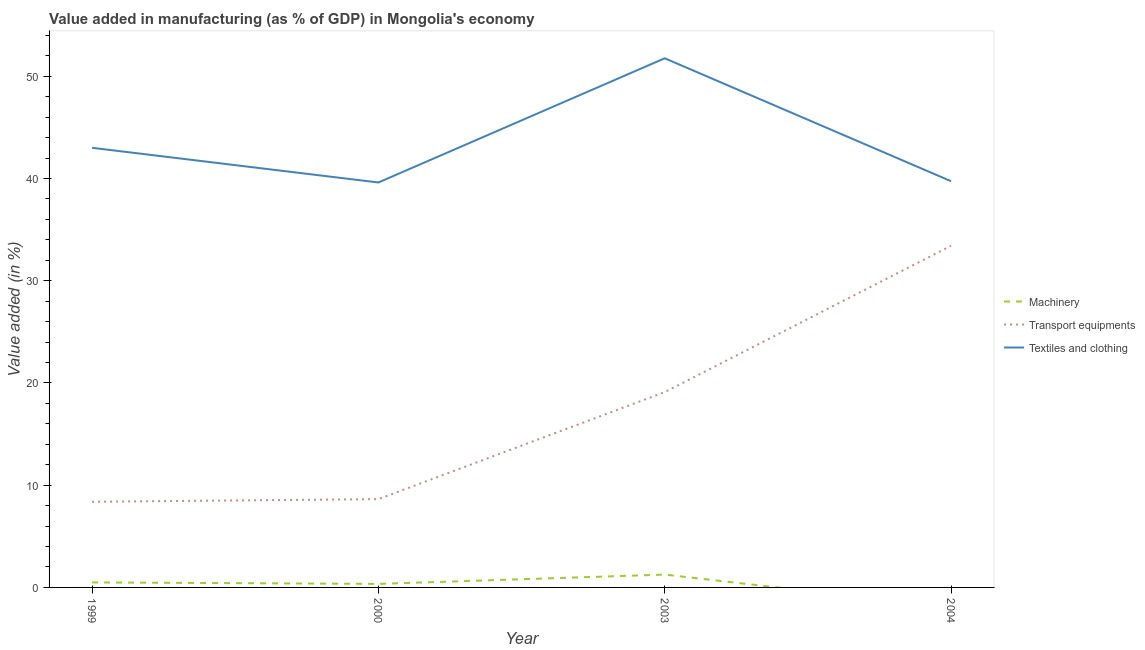How many different coloured lines are there?
Ensure brevity in your answer.  3. Does the line corresponding to value added in manufacturing transport equipments intersect with the line corresponding to value added in manufacturing machinery?
Keep it short and to the point. No. Is the number of lines equal to the number of legend labels?
Offer a very short reply. No. What is the value added in manufacturing textile and clothing in 1999?
Make the answer very short. 43.01. Across all years, what is the maximum value added in manufacturing transport equipments?
Keep it short and to the point. 33.42. Across all years, what is the minimum value added in manufacturing transport equipments?
Offer a very short reply. 8.38. What is the total value added in manufacturing transport equipments in the graph?
Offer a terse response. 69.55. What is the difference between the value added in manufacturing transport equipments in 2003 and that in 2004?
Make the answer very short. -14.32. What is the difference between the value added in manufacturing textile and clothing in 2004 and the value added in manufacturing transport equipments in 2003?
Keep it short and to the point. 20.63. What is the average value added in manufacturing transport equipments per year?
Offer a terse response. 17.39. In the year 1999, what is the difference between the value added in manufacturing machinery and value added in manufacturing transport equipments?
Keep it short and to the point. -7.89. In how many years, is the value added in manufacturing transport equipments greater than 44 %?
Offer a terse response. 0. What is the ratio of the value added in manufacturing machinery in 2000 to that in 2003?
Keep it short and to the point. 0.27. What is the difference between the highest and the second highest value added in manufacturing transport equipments?
Offer a very short reply. 14.32. What is the difference between the highest and the lowest value added in manufacturing transport equipments?
Keep it short and to the point. 25.04. In how many years, is the value added in manufacturing machinery greater than the average value added in manufacturing machinery taken over all years?
Provide a short and direct response. 1. Is the sum of the value added in manufacturing machinery in 1999 and 2000 greater than the maximum value added in manufacturing textile and clothing across all years?
Your answer should be very brief. No. Does the value added in manufacturing machinery monotonically increase over the years?
Offer a very short reply. No. Is the value added in manufacturing transport equipments strictly greater than the value added in manufacturing textile and clothing over the years?
Offer a terse response. No. Is the value added in manufacturing transport equipments strictly less than the value added in manufacturing textile and clothing over the years?
Provide a succinct answer. Yes. How many lines are there?
Your answer should be very brief. 3. Where does the legend appear in the graph?
Keep it short and to the point. Center right. How many legend labels are there?
Give a very brief answer. 3. How are the legend labels stacked?
Make the answer very short. Vertical. What is the title of the graph?
Provide a short and direct response. Value added in manufacturing (as % of GDP) in Mongolia's economy. What is the label or title of the X-axis?
Provide a short and direct response. Year. What is the label or title of the Y-axis?
Ensure brevity in your answer.  Value added (in %). What is the Value added (in %) of Machinery in 1999?
Offer a very short reply. 0.49. What is the Value added (in %) of Transport equipments in 1999?
Provide a short and direct response. 8.38. What is the Value added (in %) of Textiles and clothing in 1999?
Provide a short and direct response. 43.01. What is the Value added (in %) in Machinery in 2000?
Provide a short and direct response. 0.34. What is the Value added (in %) in Transport equipments in 2000?
Ensure brevity in your answer.  8.64. What is the Value added (in %) in Textiles and clothing in 2000?
Offer a terse response. 39.61. What is the Value added (in %) in Machinery in 2003?
Give a very brief answer. 1.26. What is the Value added (in %) in Transport equipments in 2003?
Your response must be concise. 19.11. What is the Value added (in %) of Textiles and clothing in 2003?
Provide a short and direct response. 51.76. What is the Value added (in %) in Transport equipments in 2004?
Provide a short and direct response. 33.42. What is the Value added (in %) of Textiles and clothing in 2004?
Keep it short and to the point. 39.74. Across all years, what is the maximum Value added (in %) of Machinery?
Your answer should be compact. 1.26. Across all years, what is the maximum Value added (in %) of Transport equipments?
Offer a very short reply. 33.42. Across all years, what is the maximum Value added (in %) in Textiles and clothing?
Offer a very short reply. 51.76. Across all years, what is the minimum Value added (in %) of Transport equipments?
Offer a terse response. 8.38. Across all years, what is the minimum Value added (in %) of Textiles and clothing?
Offer a very short reply. 39.61. What is the total Value added (in %) of Machinery in the graph?
Your response must be concise. 2.09. What is the total Value added (in %) of Transport equipments in the graph?
Provide a short and direct response. 69.55. What is the total Value added (in %) of Textiles and clothing in the graph?
Provide a short and direct response. 174.12. What is the difference between the Value added (in %) in Machinery in 1999 and that in 2000?
Ensure brevity in your answer.  0.15. What is the difference between the Value added (in %) in Transport equipments in 1999 and that in 2000?
Your response must be concise. -0.26. What is the difference between the Value added (in %) of Textiles and clothing in 1999 and that in 2000?
Make the answer very short. 3.39. What is the difference between the Value added (in %) of Machinery in 1999 and that in 2003?
Your answer should be very brief. -0.77. What is the difference between the Value added (in %) in Transport equipments in 1999 and that in 2003?
Provide a short and direct response. -10.73. What is the difference between the Value added (in %) in Textiles and clothing in 1999 and that in 2003?
Offer a very short reply. -8.76. What is the difference between the Value added (in %) in Transport equipments in 1999 and that in 2004?
Provide a succinct answer. -25.04. What is the difference between the Value added (in %) in Textiles and clothing in 1999 and that in 2004?
Provide a short and direct response. 3.27. What is the difference between the Value added (in %) of Machinery in 2000 and that in 2003?
Offer a very short reply. -0.91. What is the difference between the Value added (in %) in Transport equipments in 2000 and that in 2003?
Offer a very short reply. -10.47. What is the difference between the Value added (in %) in Textiles and clothing in 2000 and that in 2003?
Provide a succinct answer. -12.15. What is the difference between the Value added (in %) of Transport equipments in 2000 and that in 2004?
Your answer should be very brief. -24.79. What is the difference between the Value added (in %) in Textiles and clothing in 2000 and that in 2004?
Provide a short and direct response. -0.12. What is the difference between the Value added (in %) of Transport equipments in 2003 and that in 2004?
Your answer should be compact. -14.32. What is the difference between the Value added (in %) in Textiles and clothing in 2003 and that in 2004?
Offer a terse response. 12.03. What is the difference between the Value added (in %) in Machinery in 1999 and the Value added (in %) in Transport equipments in 2000?
Ensure brevity in your answer.  -8.15. What is the difference between the Value added (in %) of Machinery in 1999 and the Value added (in %) of Textiles and clothing in 2000?
Make the answer very short. -39.12. What is the difference between the Value added (in %) of Transport equipments in 1999 and the Value added (in %) of Textiles and clothing in 2000?
Your response must be concise. -31.23. What is the difference between the Value added (in %) of Machinery in 1999 and the Value added (in %) of Transport equipments in 2003?
Your answer should be compact. -18.62. What is the difference between the Value added (in %) in Machinery in 1999 and the Value added (in %) in Textiles and clothing in 2003?
Offer a very short reply. -51.27. What is the difference between the Value added (in %) of Transport equipments in 1999 and the Value added (in %) of Textiles and clothing in 2003?
Your response must be concise. -43.39. What is the difference between the Value added (in %) in Machinery in 1999 and the Value added (in %) in Transport equipments in 2004?
Your response must be concise. -32.93. What is the difference between the Value added (in %) of Machinery in 1999 and the Value added (in %) of Textiles and clothing in 2004?
Provide a succinct answer. -39.25. What is the difference between the Value added (in %) of Transport equipments in 1999 and the Value added (in %) of Textiles and clothing in 2004?
Keep it short and to the point. -31.36. What is the difference between the Value added (in %) of Machinery in 2000 and the Value added (in %) of Transport equipments in 2003?
Make the answer very short. -18.76. What is the difference between the Value added (in %) of Machinery in 2000 and the Value added (in %) of Textiles and clothing in 2003?
Your answer should be compact. -51.42. What is the difference between the Value added (in %) in Transport equipments in 2000 and the Value added (in %) in Textiles and clothing in 2003?
Offer a very short reply. -43.13. What is the difference between the Value added (in %) in Machinery in 2000 and the Value added (in %) in Transport equipments in 2004?
Your response must be concise. -33.08. What is the difference between the Value added (in %) of Machinery in 2000 and the Value added (in %) of Textiles and clothing in 2004?
Keep it short and to the point. -39.39. What is the difference between the Value added (in %) of Transport equipments in 2000 and the Value added (in %) of Textiles and clothing in 2004?
Offer a terse response. -31.1. What is the difference between the Value added (in %) in Machinery in 2003 and the Value added (in %) in Transport equipments in 2004?
Your response must be concise. -32.17. What is the difference between the Value added (in %) in Machinery in 2003 and the Value added (in %) in Textiles and clothing in 2004?
Provide a short and direct response. -38.48. What is the difference between the Value added (in %) of Transport equipments in 2003 and the Value added (in %) of Textiles and clothing in 2004?
Ensure brevity in your answer.  -20.63. What is the average Value added (in %) in Machinery per year?
Your answer should be very brief. 0.52. What is the average Value added (in %) in Transport equipments per year?
Your answer should be very brief. 17.39. What is the average Value added (in %) in Textiles and clothing per year?
Give a very brief answer. 43.53. In the year 1999, what is the difference between the Value added (in %) in Machinery and Value added (in %) in Transport equipments?
Your answer should be very brief. -7.89. In the year 1999, what is the difference between the Value added (in %) in Machinery and Value added (in %) in Textiles and clothing?
Ensure brevity in your answer.  -42.51. In the year 1999, what is the difference between the Value added (in %) in Transport equipments and Value added (in %) in Textiles and clothing?
Your answer should be compact. -34.63. In the year 2000, what is the difference between the Value added (in %) in Machinery and Value added (in %) in Transport equipments?
Offer a very short reply. -8.29. In the year 2000, what is the difference between the Value added (in %) in Machinery and Value added (in %) in Textiles and clothing?
Your response must be concise. -39.27. In the year 2000, what is the difference between the Value added (in %) in Transport equipments and Value added (in %) in Textiles and clothing?
Make the answer very short. -30.98. In the year 2003, what is the difference between the Value added (in %) in Machinery and Value added (in %) in Transport equipments?
Offer a very short reply. -17.85. In the year 2003, what is the difference between the Value added (in %) in Machinery and Value added (in %) in Textiles and clothing?
Give a very brief answer. -50.51. In the year 2003, what is the difference between the Value added (in %) in Transport equipments and Value added (in %) in Textiles and clothing?
Provide a short and direct response. -32.66. In the year 2004, what is the difference between the Value added (in %) in Transport equipments and Value added (in %) in Textiles and clothing?
Offer a very short reply. -6.31. What is the ratio of the Value added (in %) in Machinery in 1999 to that in 2000?
Offer a very short reply. 1.42. What is the ratio of the Value added (in %) in Textiles and clothing in 1999 to that in 2000?
Give a very brief answer. 1.09. What is the ratio of the Value added (in %) of Machinery in 1999 to that in 2003?
Give a very brief answer. 0.39. What is the ratio of the Value added (in %) in Transport equipments in 1999 to that in 2003?
Offer a very short reply. 0.44. What is the ratio of the Value added (in %) of Textiles and clothing in 1999 to that in 2003?
Give a very brief answer. 0.83. What is the ratio of the Value added (in %) of Transport equipments in 1999 to that in 2004?
Make the answer very short. 0.25. What is the ratio of the Value added (in %) of Textiles and clothing in 1999 to that in 2004?
Ensure brevity in your answer.  1.08. What is the ratio of the Value added (in %) of Machinery in 2000 to that in 2003?
Keep it short and to the point. 0.27. What is the ratio of the Value added (in %) in Transport equipments in 2000 to that in 2003?
Make the answer very short. 0.45. What is the ratio of the Value added (in %) of Textiles and clothing in 2000 to that in 2003?
Keep it short and to the point. 0.77. What is the ratio of the Value added (in %) in Transport equipments in 2000 to that in 2004?
Your answer should be compact. 0.26. What is the ratio of the Value added (in %) in Textiles and clothing in 2000 to that in 2004?
Keep it short and to the point. 1. What is the ratio of the Value added (in %) of Transport equipments in 2003 to that in 2004?
Ensure brevity in your answer.  0.57. What is the ratio of the Value added (in %) in Textiles and clothing in 2003 to that in 2004?
Offer a very short reply. 1.3. What is the difference between the highest and the second highest Value added (in %) of Machinery?
Keep it short and to the point. 0.77. What is the difference between the highest and the second highest Value added (in %) in Transport equipments?
Offer a terse response. 14.32. What is the difference between the highest and the second highest Value added (in %) of Textiles and clothing?
Provide a succinct answer. 8.76. What is the difference between the highest and the lowest Value added (in %) in Machinery?
Provide a succinct answer. 1.26. What is the difference between the highest and the lowest Value added (in %) of Transport equipments?
Give a very brief answer. 25.04. What is the difference between the highest and the lowest Value added (in %) of Textiles and clothing?
Provide a short and direct response. 12.15. 